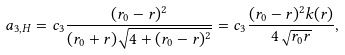<formula> <loc_0><loc_0><loc_500><loc_500>a _ { 3 , H } = c _ { 3 } \frac { ( r _ { 0 } - r ) ^ { 2 } } { ( r _ { 0 } + r ) \sqrt { 4 + ( r _ { 0 } - r ) ^ { 2 } } } = c _ { 3 } \frac { ( r _ { 0 } - r ) ^ { 2 } k ( r ) } { 4 \sqrt { r _ { 0 } r } } ,</formula> 